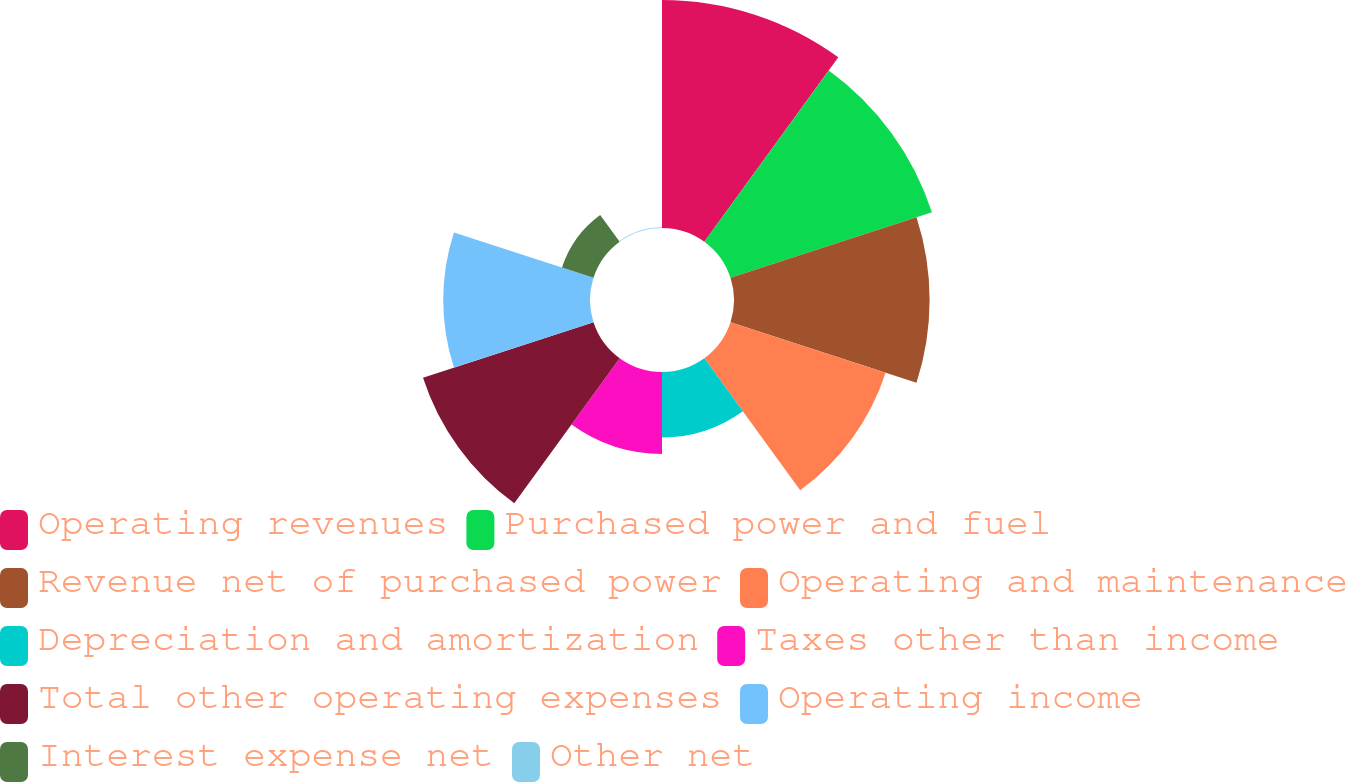Convert chart. <chart><loc_0><loc_0><loc_500><loc_500><pie_chart><fcel>Operating revenues<fcel>Purchased power and fuel<fcel>Revenue net of purchased power<fcel>Operating and maintenance<fcel>Depreciation and amortization<fcel>Taxes other than income<fcel>Total other operating expenses<fcel>Operating income<fcel>Interest expense net<fcel>Other net<nl><fcel>17.46%<fcel>16.22%<fcel>14.98%<fcel>12.49%<fcel>5.02%<fcel>6.27%<fcel>13.73%<fcel>11.24%<fcel>2.54%<fcel>0.05%<nl></chart> 